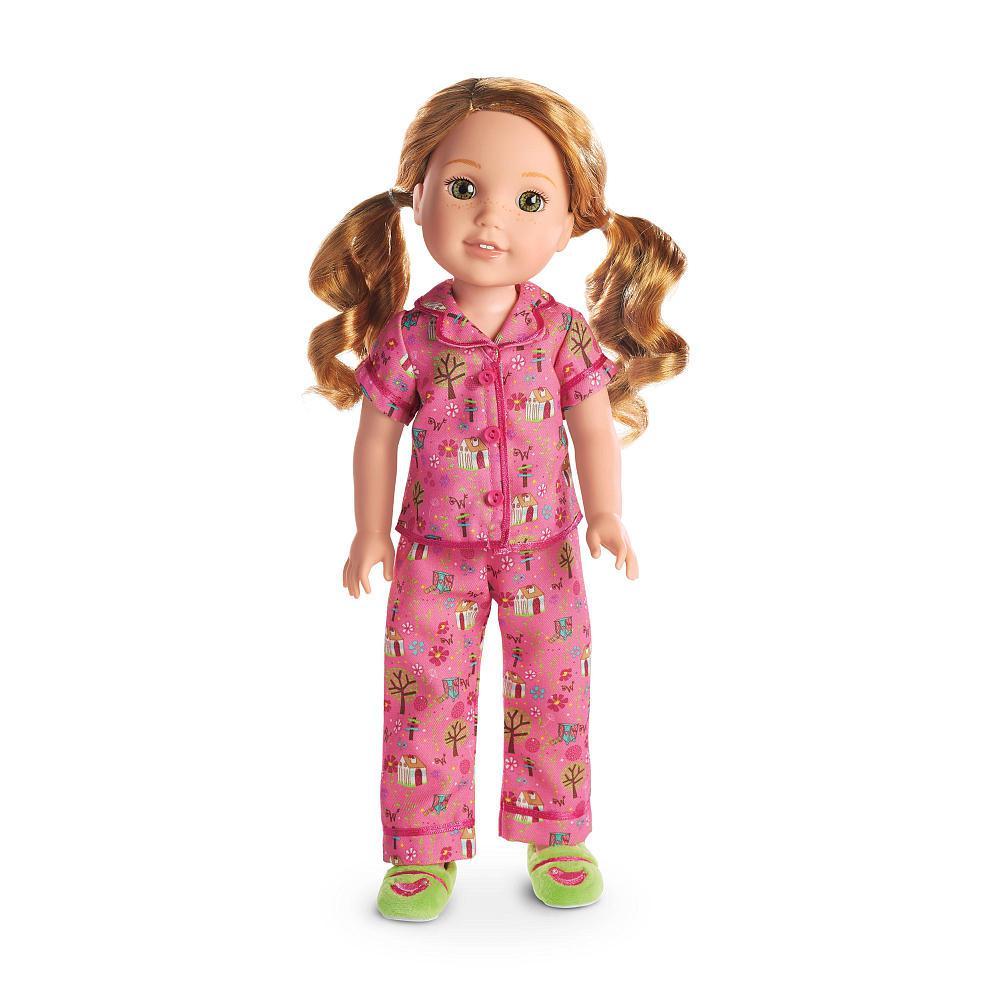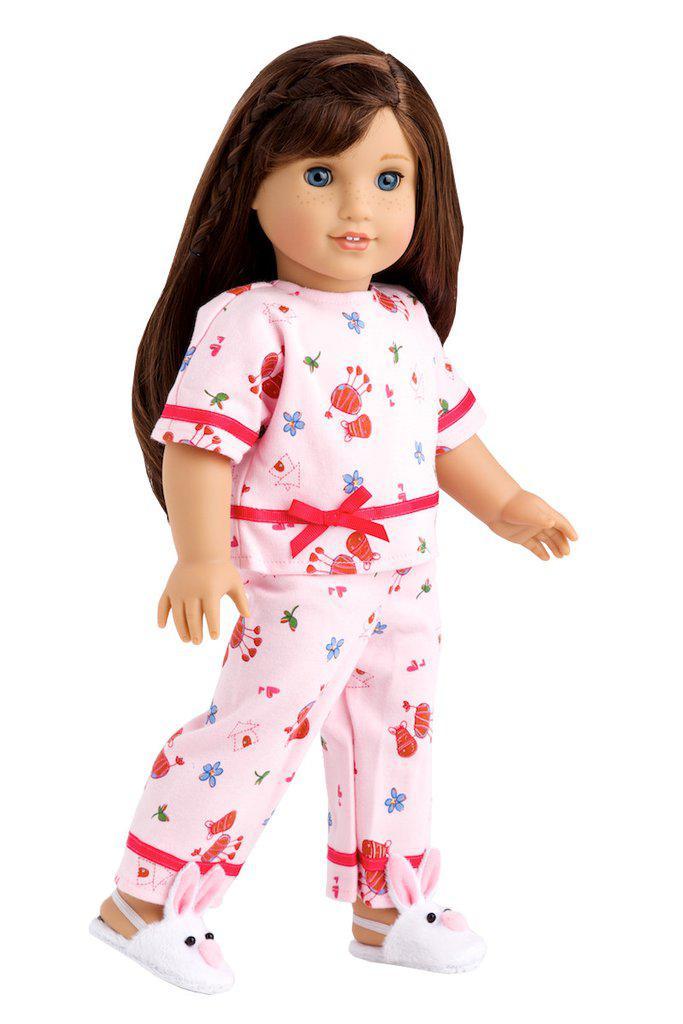The first image is the image on the left, the second image is the image on the right. Examine the images to the left and right. Is the description "there is a doll in pajamas and wearing white bunny slippers" accurate? Answer yes or no. Yes. The first image is the image on the left, the second image is the image on the right. Considering the images on both sides, is "One image shows a doll wearing her hair in pigtails." valid? Answer yes or no. Yes. 